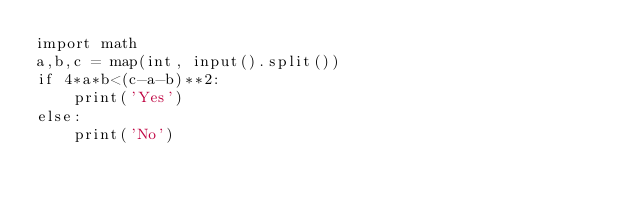Convert code to text. <code><loc_0><loc_0><loc_500><loc_500><_Python_>import math
a,b,c = map(int, input().split())
if 4*a*b<(c-a-b)**2:
    print('Yes')
else:
    print('No')</code> 